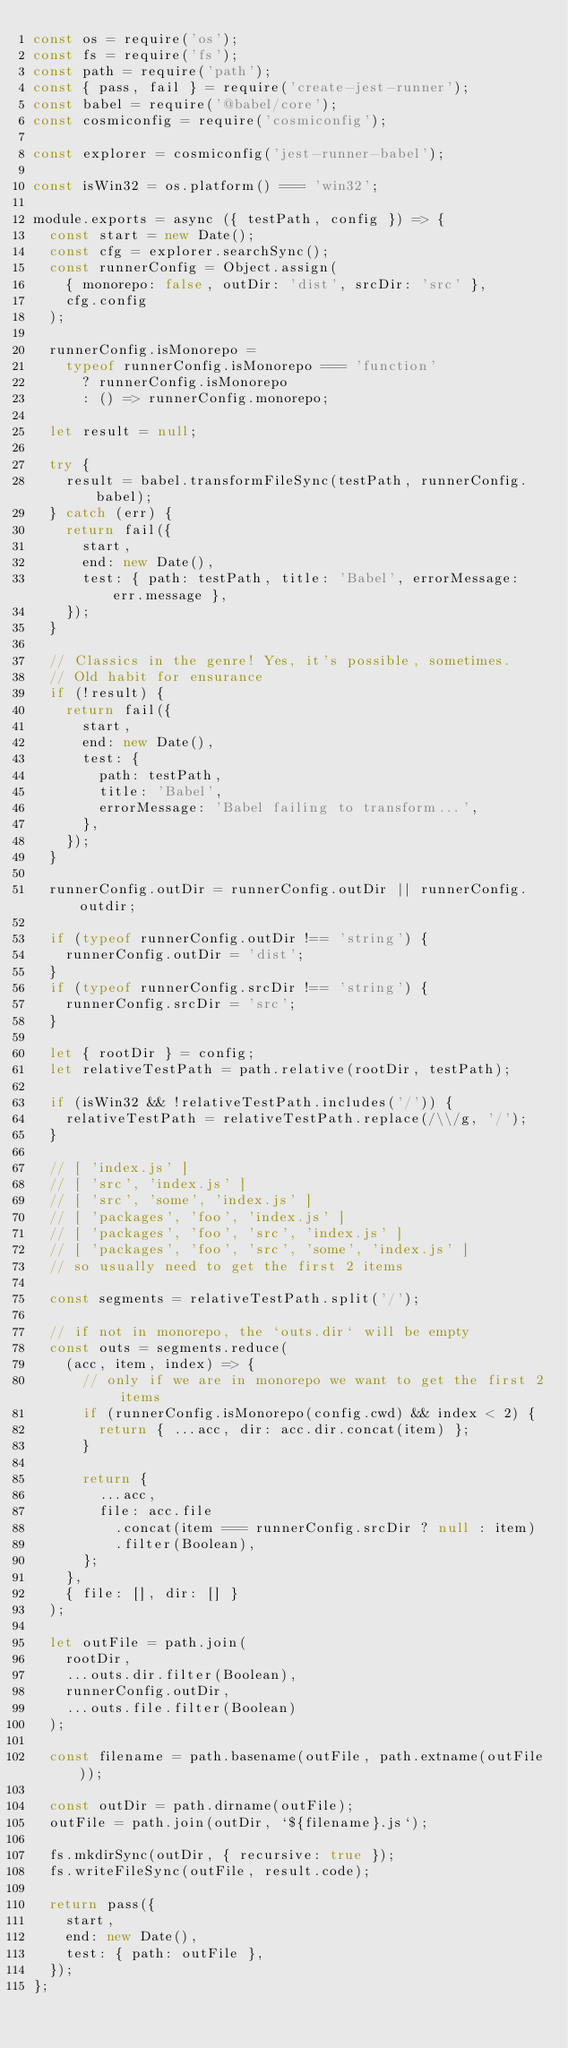<code> <loc_0><loc_0><loc_500><loc_500><_JavaScript_>const os = require('os');
const fs = require('fs');
const path = require('path');
const { pass, fail } = require('create-jest-runner');
const babel = require('@babel/core');
const cosmiconfig = require('cosmiconfig');

const explorer = cosmiconfig('jest-runner-babel');

const isWin32 = os.platform() === 'win32';

module.exports = async ({ testPath, config }) => {
  const start = new Date();
  const cfg = explorer.searchSync();
  const runnerConfig = Object.assign(
    { monorepo: false, outDir: 'dist', srcDir: 'src' },
    cfg.config
  );

  runnerConfig.isMonorepo =
    typeof runnerConfig.isMonorepo === 'function'
      ? runnerConfig.isMonorepo
      : () => runnerConfig.monorepo;

  let result = null;

  try {
    result = babel.transformFileSync(testPath, runnerConfig.babel);
  } catch (err) {
    return fail({
      start,
      end: new Date(),
      test: { path: testPath, title: 'Babel', errorMessage: err.message },
    });
  }

  // Classics in the genre! Yes, it's possible, sometimes.
  // Old habit for ensurance
  if (!result) {
    return fail({
      start,
      end: new Date(),
      test: {
        path: testPath,
        title: 'Babel',
        errorMessage: 'Babel failing to transform...',
      },
    });
  }

  runnerConfig.outDir = runnerConfig.outDir || runnerConfig.outdir;

  if (typeof runnerConfig.outDir !== 'string') {
    runnerConfig.outDir = 'dist';
  }
  if (typeof runnerConfig.srcDir !== 'string') {
    runnerConfig.srcDir = 'src';
  }

  let { rootDir } = config;
  let relativeTestPath = path.relative(rootDir, testPath);

  if (isWin32 && !relativeTestPath.includes('/')) {
    relativeTestPath = relativeTestPath.replace(/\\/g, '/');
  }

  // [ 'index.js' ]
  // [ 'src', 'index.js' ]
  // [ 'src', 'some', 'index.js' ]
  // [ 'packages', 'foo', 'index.js' ]
  // [ 'packages', 'foo', 'src', 'index.js' ]
  // [ 'packages', 'foo', 'src', 'some', 'index.js' ]
  // so usually need to get the first 2 items

  const segments = relativeTestPath.split('/');

  // if not in monorepo, the `outs.dir` will be empty
  const outs = segments.reduce(
    (acc, item, index) => {
      // only if we are in monorepo we want to get the first 2 items
      if (runnerConfig.isMonorepo(config.cwd) && index < 2) {
        return { ...acc, dir: acc.dir.concat(item) };
      }

      return {
        ...acc,
        file: acc.file
          .concat(item === runnerConfig.srcDir ? null : item)
          .filter(Boolean),
      };
    },
    { file: [], dir: [] }
  );

  let outFile = path.join(
    rootDir,
    ...outs.dir.filter(Boolean),
    runnerConfig.outDir,
    ...outs.file.filter(Boolean)
  );

  const filename = path.basename(outFile, path.extname(outFile));

  const outDir = path.dirname(outFile);
  outFile = path.join(outDir, `${filename}.js`);

  fs.mkdirSync(outDir, { recursive: true });
  fs.writeFileSync(outFile, result.code);

  return pass({
    start,
    end: new Date(),
    test: { path: outFile },
  });
};
</code> 